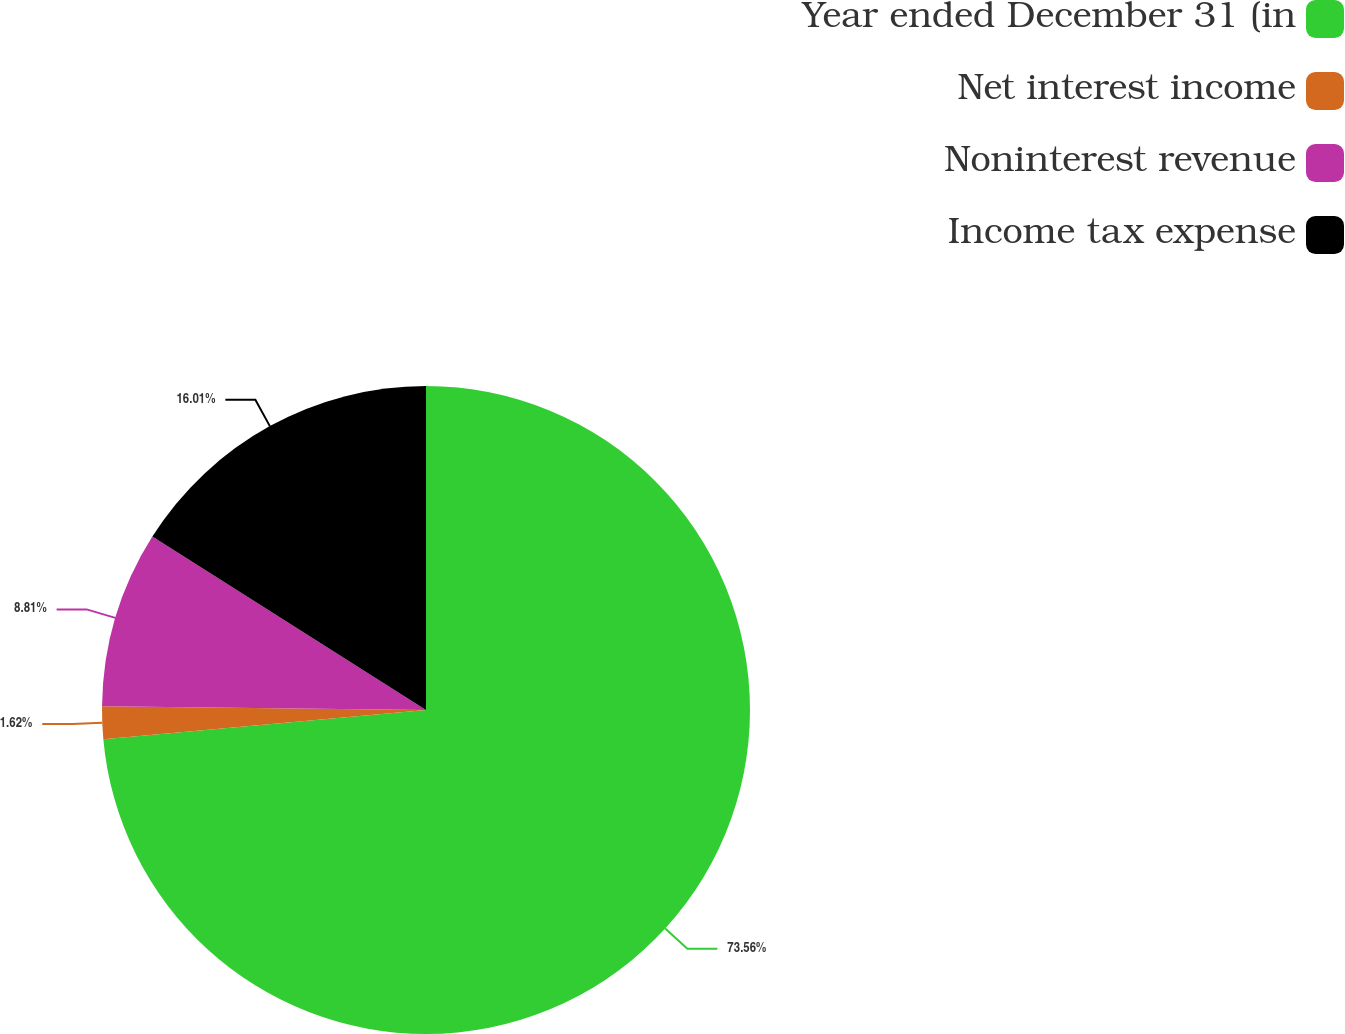<chart> <loc_0><loc_0><loc_500><loc_500><pie_chart><fcel>Year ended December 31 (in<fcel>Net interest income<fcel>Noninterest revenue<fcel>Income tax expense<nl><fcel>73.57%<fcel>1.62%<fcel>8.81%<fcel>16.01%<nl></chart> 